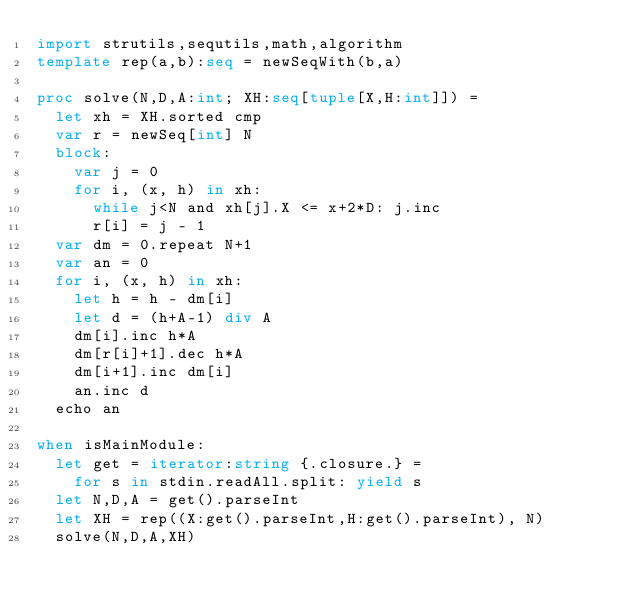Convert code to text. <code><loc_0><loc_0><loc_500><loc_500><_Nim_>import strutils,sequtils,math,algorithm
template rep(a,b):seq = newSeqWith(b,a)

proc solve(N,D,A:int; XH:seq[tuple[X,H:int]]) =
  let xh = XH.sorted cmp
  var r = newSeq[int] N
  block:
    var j = 0
    for i, (x, h) in xh:
      while j<N and xh[j].X <= x+2*D: j.inc
      r[i] = j - 1
  var dm = 0.repeat N+1
  var an = 0
  for i, (x, h) in xh:
    let h = h - dm[i]
    let d = (h+A-1) div A
    dm[i].inc h*A
    dm[r[i]+1].dec h*A
    dm[i+1].inc dm[i]
    an.inc d
  echo an

when isMainModule:
  let get = iterator:string {.closure.} = 
    for s in stdin.readAll.split: yield s
  let N,D,A = get().parseInt
  let XH = rep((X:get().parseInt,H:get().parseInt), N)
  solve(N,D,A,XH)

</code> 